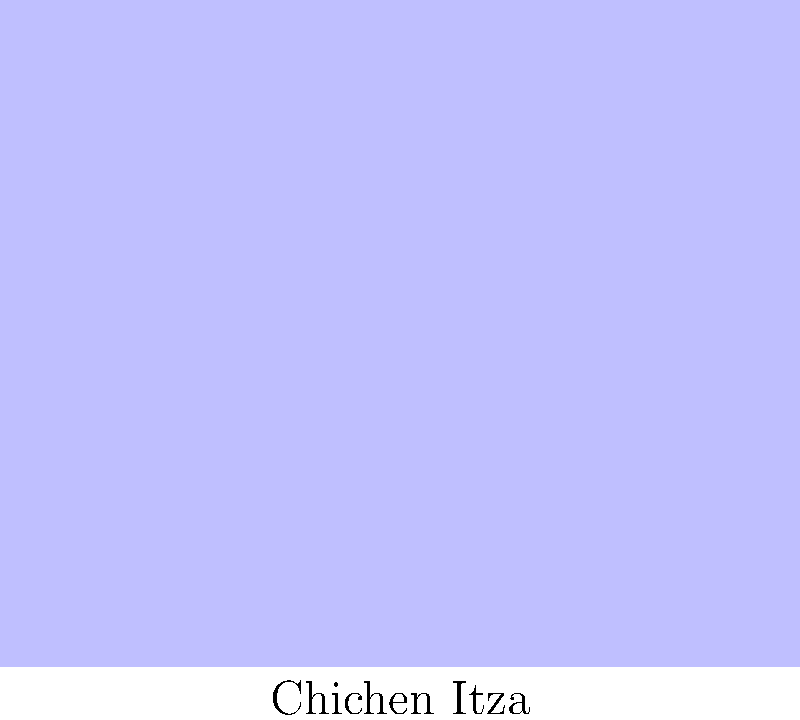Which famous Mayan ruin is depicted in this architectural sketch, known for its step pyramid design and located about 120 km from Mérida, the capital of Yucatán? To identify this Mayan ruin, let's analyze the key features of the sketch:

1. The central structure is a step pyramid, a common feature in Mayan architecture.
2. There's a prominent staircase leading to the top of the pyramid.
3. A temple-like structure is visible at the top of the pyramid.
4. The sketch is labeled "Chichen Itza" at the bottom.

These features, especially the step pyramid design with a central staircase, are characteristic of El Castillo (also known as the Temple of Kukulcan) at Chichen Itza. This iconic structure is one of the most recognizable Mayan ruins and is indeed located about 120 km from Mérida.

Chichen Itza is a pre-Columbian city built by the Maya civilization, located in the Yucatán Peninsula. It was one of the largest Maya cities and is now one of the most visited archaeological sites in Mexico. The site's proximity to the Yucatan Peninsula makes it particularly relevant to the given persona of a Mexican living in that area.
Answer: Chichen Itza 